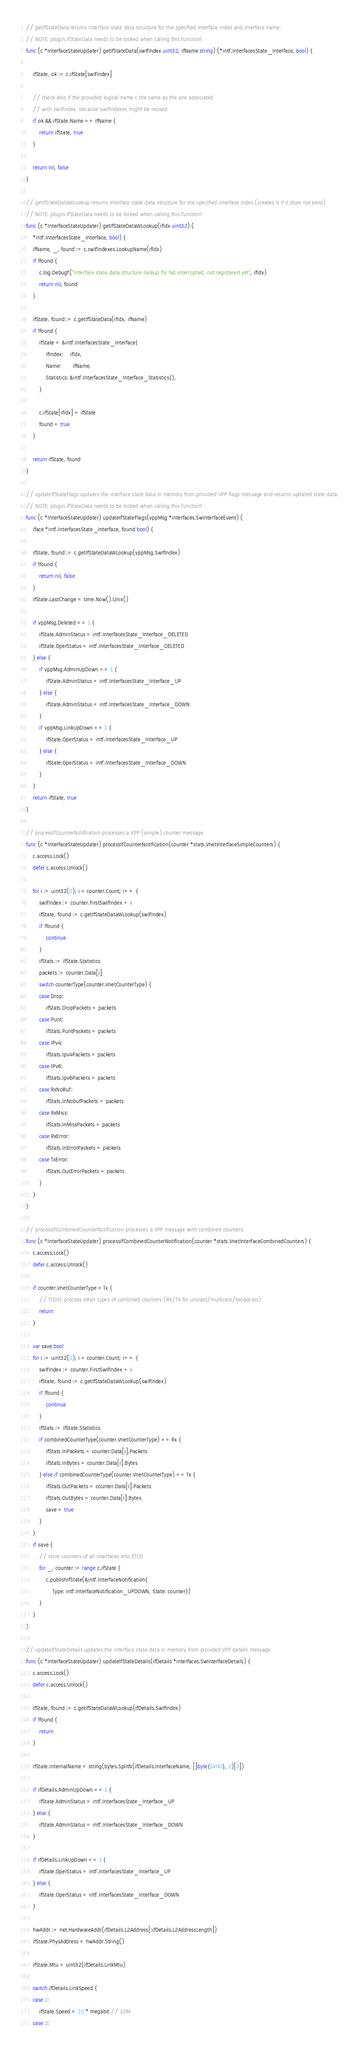Convert code to text. <code><loc_0><loc_0><loc_500><loc_500><_Go_>// getIfStateData returns interface state data structure for the specified interface index and interface name.
// NOTE: plugin.ifStateData needs to be locked when calling this function!
func (c *InterfaceStateUpdater) getIfStateData(swIfIndex uint32, ifName string) (*intf.InterfacesState_Interface, bool) {

	ifState, ok := c.ifState[swIfIndex]

	// check also if the provided logical name c the same as the one associated
	// with swIfIndex, because swIfIndexes might be reused
	if ok && ifState.Name == ifName {
		return ifState, true
	}

	return nil, false
}

// getIfStateDataWLookup returns interface state data structure for the specified interface index (creates it if it does not exist).
// NOTE: plugin.ifStateData needs to be locked when calling this function!
func (c *InterfaceStateUpdater) getIfStateDataWLookup(ifIdx uint32) (
	*intf.InterfacesState_Interface, bool) {
	ifName, _, found := c.swIfIndexes.LookupName(ifIdx)
	if !found {
		c.log.Debugf("Interface state data structure lookup for %d interrupted, not registered yet", ifIdx)
		return nil, found
	}

	ifState, found := c.getIfStateData(ifIdx, ifName)
	if !found {
		ifState = &intf.InterfacesState_Interface{
			IfIndex:    ifIdx,
			Name:       ifName,
			Statistics: &intf.InterfacesState_Interface_Statistics{},
		}

		c.ifState[ifIdx] = ifState
		found = true
	}

	return ifState, found
}

// updateIfStateFlags updates the interface state data in memory from provided VPP flags message and returns updated state data.
// NOTE: plugin.ifStateData needs to be locked when calling this function!
func (c *InterfaceStateUpdater) updateIfStateFlags(vppMsg *interfaces.SwInterfaceEvent) (
	iface *intf.InterfacesState_Interface, found bool) {

	ifState, found := c.getIfStateDataWLookup(vppMsg.SwIfIndex)
	if !found {
		return nil, false
	}
	ifState.LastChange = time.Now().Unix()

	if vppMsg.Deleted == 1 {
		ifState.AdminStatus = intf.InterfacesState_Interface_DELETED
		ifState.OperStatus = intf.InterfacesState_Interface_DELETED
	} else {
		if vppMsg.AdminUpDown == 1 {
			ifState.AdminStatus = intf.InterfacesState_Interface_UP
		} else {
			ifState.AdminStatus = intf.InterfacesState_Interface_DOWN
		}
		if vppMsg.LinkUpDown == 1 {
			ifState.OperStatus = intf.InterfacesState_Interface_UP
		} else {
			ifState.OperStatus = intf.InterfacesState_Interface_DOWN
		}
	}
	return ifState, true
}

// processIfCounterNotification processes a VPP (simple) counter message.
func (c *InterfaceStateUpdater) processIfCounterNotification(counter *stats.VnetInterfaceSimpleCounters) {
	c.access.Lock()
	defer c.access.Unlock()

	for i := uint32(0); i < counter.Count; i++ {
		swIfIndex := counter.FirstSwIfIndex + i
		ifState, found := c.getIfStateDataWLookup(swIfIndex)
		if !found {
			continue
		}
		ifStats := ifState.Statistics
		packets := counter.Data[i]
		switch counterType(counter.VnetCounterType) {
		case Drop:
			ifStats.DropPackets = packets
		case Punt:
			ifStats.PuntPackets = packets
		case IPv4:
			ifStats.Ipv4Packets = packets
		case IPv6:
			ifStats.Ipv6Packets = packets
		case RxNoBuf:
			ifStats.InNobufPackets = packets
		case RxMiss:
			ifStats.InMissPackets = packets
		case RxError:
			ifStats.InErrorPackets = packets
		case TxError:
			ifStats.OutErrorPackets = packets
		}
	}
}

// processIfCombinedCounterNotification processes a VPP message with combined counters.
func (c *InterfaceStateUpdater) processIfCombinedCounterNotification(counter *stats.VnetInterfaceCombinedCounters) {
	c.access.Lock()
	defer c.access.Unlock()

	if counter.VnetCounterType > Tx {
		// TODO: process other types of combined counters (RX/TX for unicast/multicast/broadcast)
		return
	}

	var save bool
	for i := uint32(0); i < counter.Count; i++ {
		swIfIndex := counter.FirstSwIfIndex + i
		ifState, found := c.getIfStateDataWLookup(swIfIndex)
		if !found {
			continue
		}
		ifStats := ifState.Statistics
		if combinedCounterType(counter.VnetCounterType) == Rx {
			ifStats.InPackets = counter.Data[i].Packets
			ifStats.InBytes = counter.Data[i].Bytes
		} else if combinedCounterType(counter.VnetCounterType) == Tx {
			ifStats.OutPackets = counter.Data[i].Packets
			ifStats.OutBytes = counter.Data[i].Bytes
			save = true
		}
	}
	if save {
		// store counters of all interfaces into ETCD
		for _, counter := range c.ifState {
			c.publishIfState(&intf.InterfaceNotification{
				Type: intf.InterfaceNotification_UPDOWN, State: counter})
		}
	}
}

// updateIfStateDetails updates the interface state data in memory from provided VPP details message.
func (c *InterfaceStateUpdater) updateIfStateDetails(ifDetails *interfaces.SwInterfaceDetails) {
	c.access.Lock()
	defer c.access.Unlock()

	ifState, found := c.getIfStateDataWLookup(ifDetails.SwIfIndex)
	if !found {
		return
	}

	ifState.InternalName = string(bytes.SplitN(ifDetails.InterfaceName, []byte{0x00}, 2)[0])

	if ifDetails.AdminUpDown == 1 {
		ifState.AdminStatus = intf.InterfacesState_Interface_UP
	} else {
		ifState.AdminStatus = intf.InterfacesState_Interface_DOWN
	}

	if ifDetails.LinkUpDown == 1 {
		ifState.OperStatus = intf.InterfacesState_Interface_UP
	} else {
		ifState.OperStatus = intf.InterfacesState_Interface_DOWN
	}

	hwAddr := net.HardwareAddr(ifDetails.L2Address[:ifDetails.L2AddressLength])
	ifState.PhysAddress = hwAddr.String()

	ifState.Mtu = uint32(ifDetails.LinkMtu)

	switch ifDetails.LinkSpeed {
	case 1:
		ifState.Speed = 10 * megabit // 10M
	case 2:</code> 